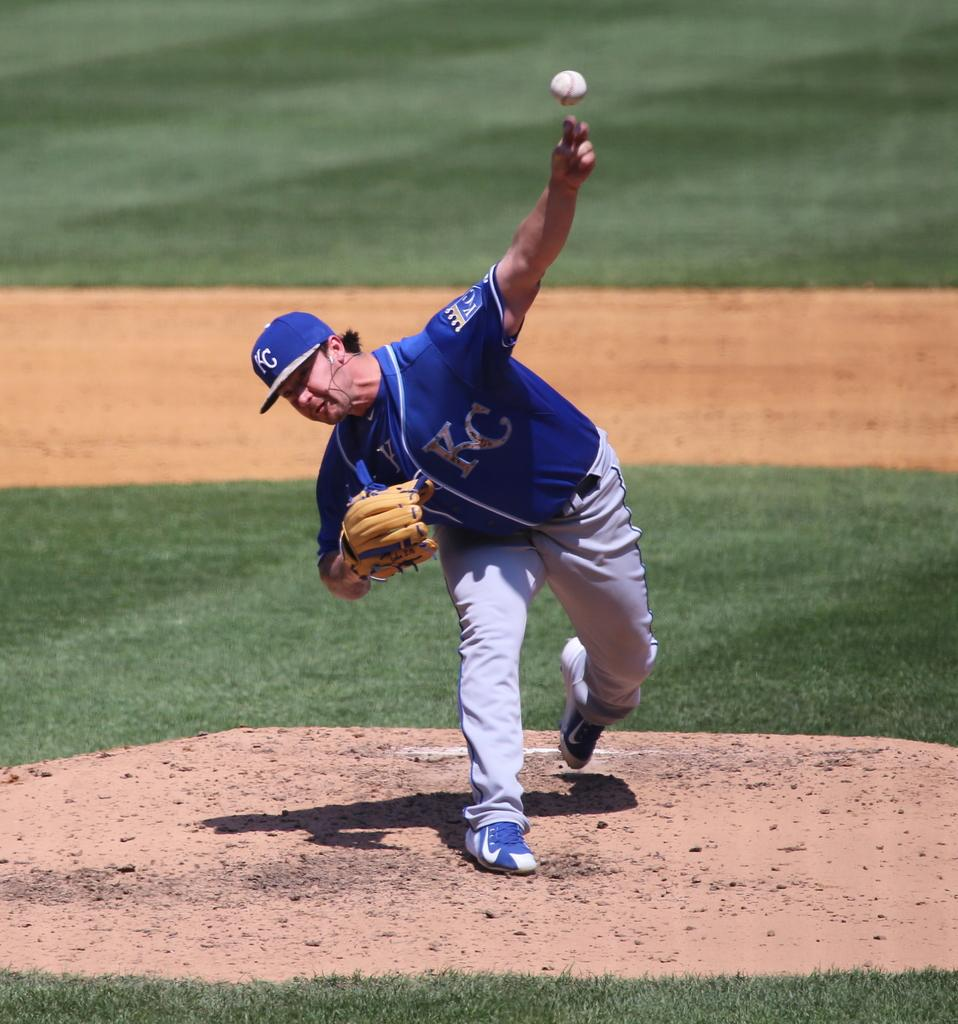Provide a one-sentence caption for the provided image. a player from KC getting ready to throw the ball. 